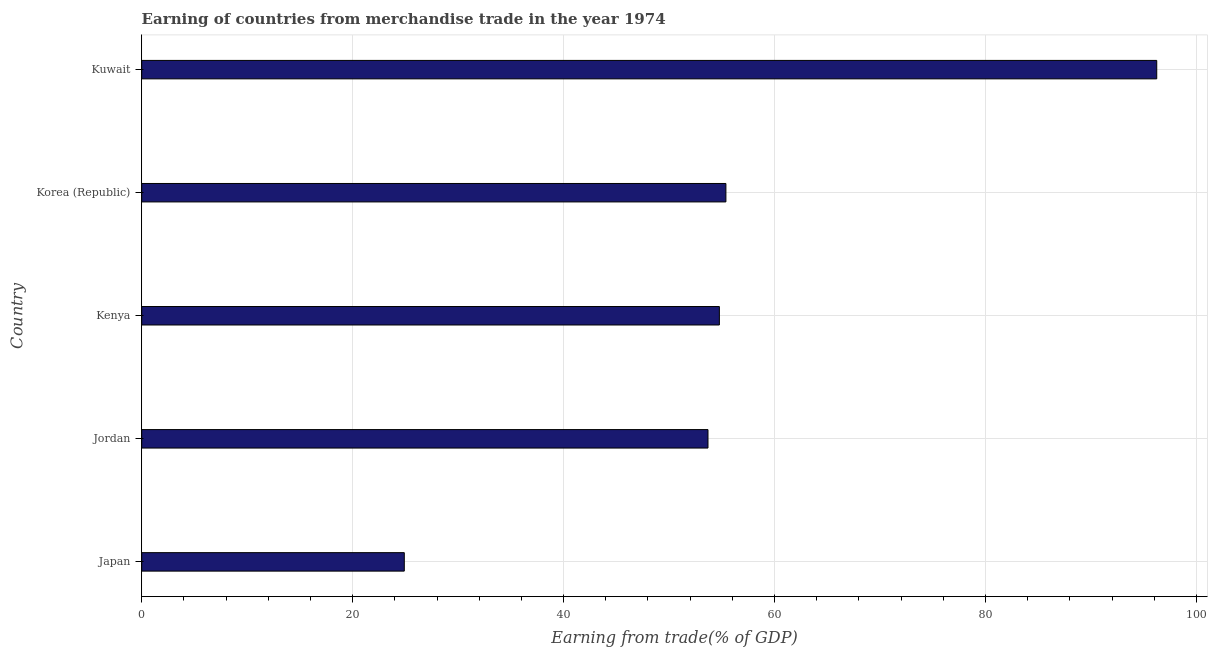Does the graph contain any zero values?
Provide a short and direct response. No. Does the graph contain grids?
Provide a succinct answer. Yes. What is the title of the graph?
Offer a terse response. Earning of countries from merchandise trade in the year 1974. What is the label or title of the X-axis?
Provide a succinct answer. Earning from trade(% of GDP). What is the earning from merchandise trade in Japan?
Give a very brief answer. 24.9. Across all countries, what is the maximum earning from merchandise trade?
Offer a terse response. 96.24. Across all countries, what is the minimum earning from merchandise trade?
Keep it short and to the point. 24.9. In which country was the earning from merchandise trade maximum?
Ensure brevity in your answer.  Kuwait. What is the sum of the earning from merchandise trade?
Offer a terse response. 284.98. What is the difference between the earning from merchandise trade in Korea (Republic) and Kuwait?
Offer a very short reply. -40.85. What is the average earning from merchandise trade per country?
Make the answer very short. 57. What is the median earning from merchandise trade?
Keep it short and to the point. 54.77. What is the ratio of the earning from merchandise trade in Jordan to that in Kenya?
Offer a very short reply. 0.98. Is the earning from merchandise trade in Jordan less than that in Korea (Republic)?
Your answer should be compact. Yes. Is the difference between the earning from merchandise trade in Japan and Jordan greater than the difference between any two countries?
Your answer should be very brief. No. What is the difference between the highest and the second highest earning from merchandise trade?
Offer a very short reply. 40.85. Is the sum of the earning from merchandise trade in Japan and Jordan greater than the maximum earning from merchandise trade across all countries?
Give a very brief answer. No. What is the difference between the highest and the lowest earning from merchandise trade?
Your answer should be compact. 71.34. In how many countries, is the earning from merchandise trade greater than the average earning from merchandise trade taken over all countries?
Your answer should be very brief. 1. How many countries are there in the graph?
Keep it short and to the point. 5. What is the difference between two consecutive major ticks on the X-axis?
Make the answer very short. 20. What is the Earning from trade(% of GDP) of Japan?
Keep it short and to the point. 24.9. What is the Earning from trade(% of GDP) in Jordan?
Offer a terse response. 53.69. What is the Earning from trade(% of GDP) of Kenya?
Your answer should be compact. 54.77. What is the Earning from trade(% of GDP) of Korea (Republic)?
Your response must be concise. 55.39. What is the Earning from trade(% of GDP) in Kuwait?
Provide a succinct answer. 96.24. What is the difference between the Earning from trade(% of GDP) in Japan and Jordan?
Offer a terse response. -28.79. What is the difference between the Earning from trade(% of GDP) in Japan and Kenya?
Your answer should be compact. -29.87. What is the difference between the Earning from trade(% of GDP) in Japan and Korea (Republic)?
Provide a succinct answer. -30.49. What is the difference between the Earning from trade(% of GDP) in Japan and Kuwait?
Ensure brevity in your answer.  -71.34. What is the difference between the Earning from trade(% of GDP) in Jordan and Kenya?
Keep it short and to the point. -1.08. What is the difference between the Earning from trade(% of GDP) in Jordan and Korea (Republic)?
Your answer should be compact. -1.7. What is the difference between the Earning from trade(% of GDP) in Jordan and Kuwait?
Give a very brief answer. -42.55. What is the difference between the Earning from trade(% of GDP) in Kenya and Korea (Republic)?
Offer a very short reply. -0.62. What is the difference between the Earning from trade(% of GDP) in Kenya and Kuwait?
Provide a short and direct response. -41.47. What is the difference between the Earning from trade(% of GDP) in Korea (Republic) and Kuwait?
Make the answer very short. -40.85. What is the ratio of the Earning from trade(% of GDP) in Japan to that in Jordan?
Your response must be concise. 0.46. What is the ratio of the Earning from trade(% of GDP) in Japan to that in Kenya?
Your answer should be very brief. 0.46. What is the ratio of the Earning from trade(% of GDP) in Japan to that in Korea (Republic)?
Your answer should be very brief. 0.45. What is the ratio of the Earning from trade(% of GDP) in Japan to that in Kuwait?
Provide a short and direct response. 0.26. What is the ratio of the Earning from trade(% of GDP) in Jordan to that in Kuwait?
Give a very brief answer. 0.56. What is the ratio of the Earning from trade(% of GDP) in Kenya to that in Korea (Republic)?
Offer a very short reply. 0.99. What is the ratio of the Earning from trade(% of GDP) in Kenya to that in Kuwait?
Make the answer very short. 0.57. What is the ratio of the Earning from trade(% of GDP) in Korea (Republic) to that in Kuwait?
Offer a very short reply. 0.58. 